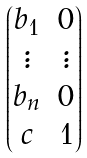<formula> <loc_0><loc_0><loc_500><loc_500>\begin{pmatrix} b _ { 1 } & 0 \\ \vdots & \vdots \\ b _ { n } & 0 \\ c & 1 \end{pmatrix}</formula> 